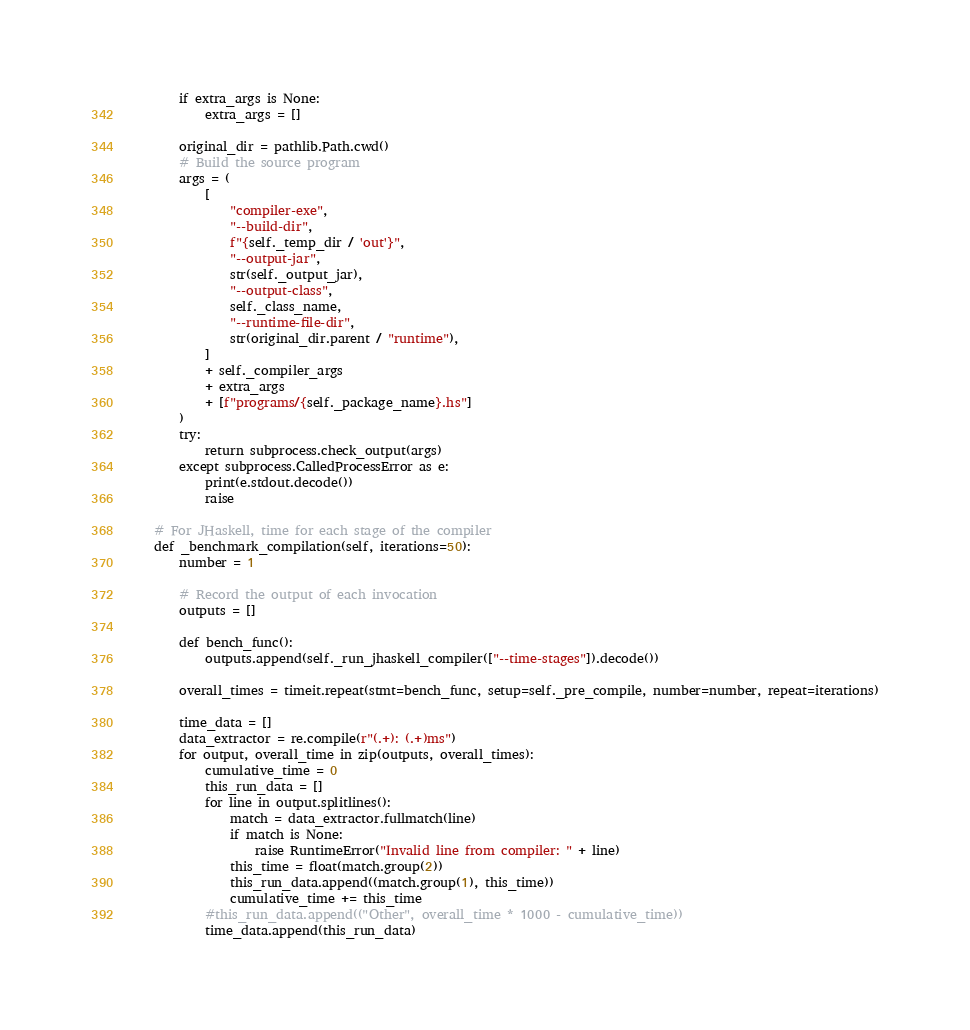<code> <loc_0><loc_0><loc_500><loc_500><_Python_>        if extra_args is None:
            extra_args = []

        original_dir = pathlib.Path.cwd()
        # Build the source program
        args = (
            [
                "compiler-exe",
                "--build-dir",
                f"{self._temp_dir / 'out'}",
                "--output-jar",
                str(self._output_jar),
                "--output-class",
                self._class_name,
                "--runtime-file-dir",
                str(original_dir.parent / "runtime"),
            ]
            + self._compiler_args
            + extra_args
            + [f"programs/{self._package_name}.hs"]
        )
        try:
            return subprocess.check_output(args)
        except subprocess.CalledProcessError as e:
            print(e.stdout.decode())
            raise

    # For JHaskell, time for each stage of the compiler
    def _benchmark_compilation(self, iterations=50):
        number = 1

        # Record the output of each invocation
        outputs = []

        def bench_func():
            outputs.append(self._run_jhaskell_compiler(["--time-stages"]).decode())

        overall_times = timeit.repeat(stmt=bench_func, setup=self._pre_compile, number=number, repeat=iterations)

        time_data = []
        data_extractor = re.compile(r"(.+): (.+)ms")
        for output, overall_time in zip(outputs, overall_times):
            cumulative_time = 0
            this_run_data = []
            for line in output.splitlines():
                match = data_extractor.fullmatch(line)
                if match is None:
                    raise RuntimeError("Invalid line from compiler: " + line)
                this_time = float(match.group(2))
                this_run_data.append((match.group(1), this_time))
                cumulative_time += this_time
            #this_run_data.append(("Other", overall_time * 1000 - cumulative_time))
            time_data.append(this_run_data)</code> 